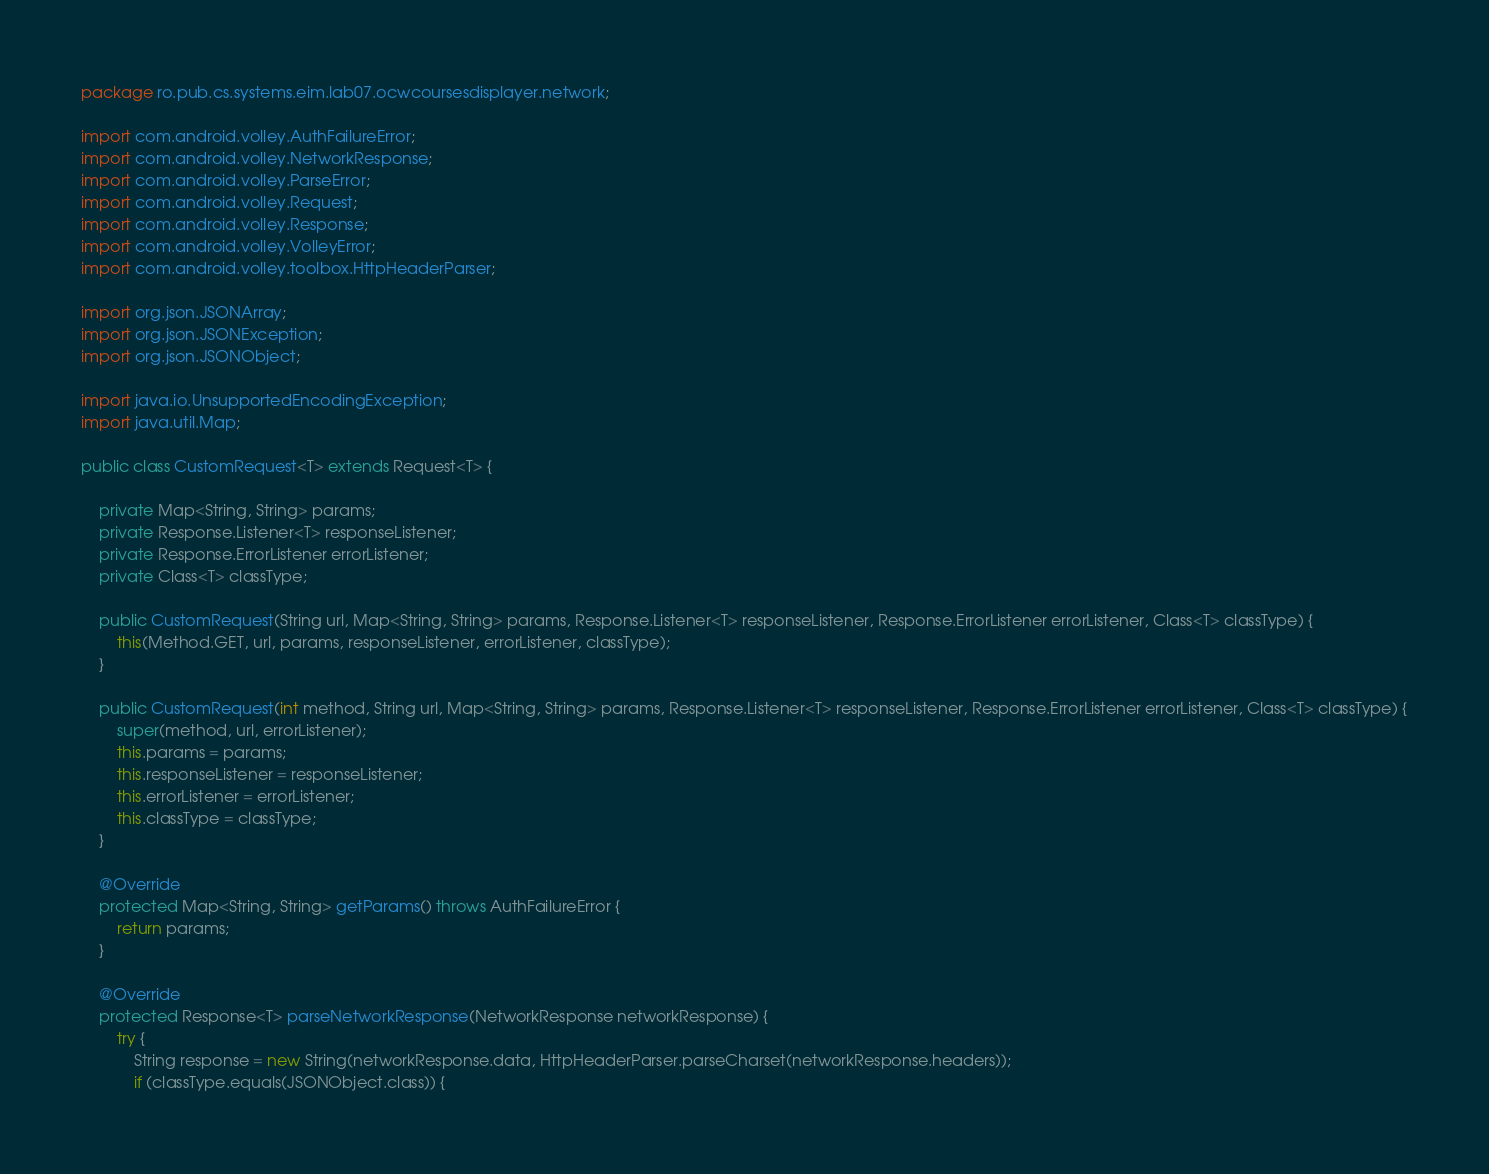<code> <loc_0><loc_0><loc_500><loc_500><_Java_>package ro.pub.cs.systems.eim.lab07.ocwcoursesdisplayer.network;

import com.android.volley.AuthFailureError;
import com.android.volley.NetworkResponse;
import com.android.volley.ParseError;
import com.android.volley.Request;
import com.android.volley.Response;
import com.android.volley.VolleyError;
import com.android.volley.toolbox.HttpHeaderParser;

import org.json.JSONArray;
import org.json.JSONException;
import org.json.JSONObject;

import java.io.UnsupportedEncodingException;
import java.util.Map;

public class CustomRequest<T> extends Request<T> {

    private Map<String, String> params;
    private Response.Listener<T> responseListener;
    private Response.ErrorListener errorListener;
    private Class<T> classType;

    public CustomRequest(String url, Map<String, String> params, Response.Listener<T> responseListener, Response.ErrorListener errorListener, Class<T> classType) {
        this(Method.GET, url, params, responseListener, errorListener, classType);
    }

    public CustomRequest(int method, String url, Map<String, String> params, Response.Listener<T> responseListener, Response.ErrorListener errorListener, Class<T> classType) {
        super(method, url, errorListener);
        this.params = params;
        this.responseListener = responseListener;
        this.errorListener = errorListener;
        this.classType = classType;
    }

    @Override
    protected Map<String, String> getParams() throws AuthFailureError {
        return params;
    }

    @Override
    protected Response<T> parseNetworkResponse(NetworkResponse networkResponse) {
        try {
            String response = new String(networkResponse.data, HttpHeaderParser.parseCharset(networkResponse.headers));
            if (classType.equals(JSONObject.class)) {</code> 